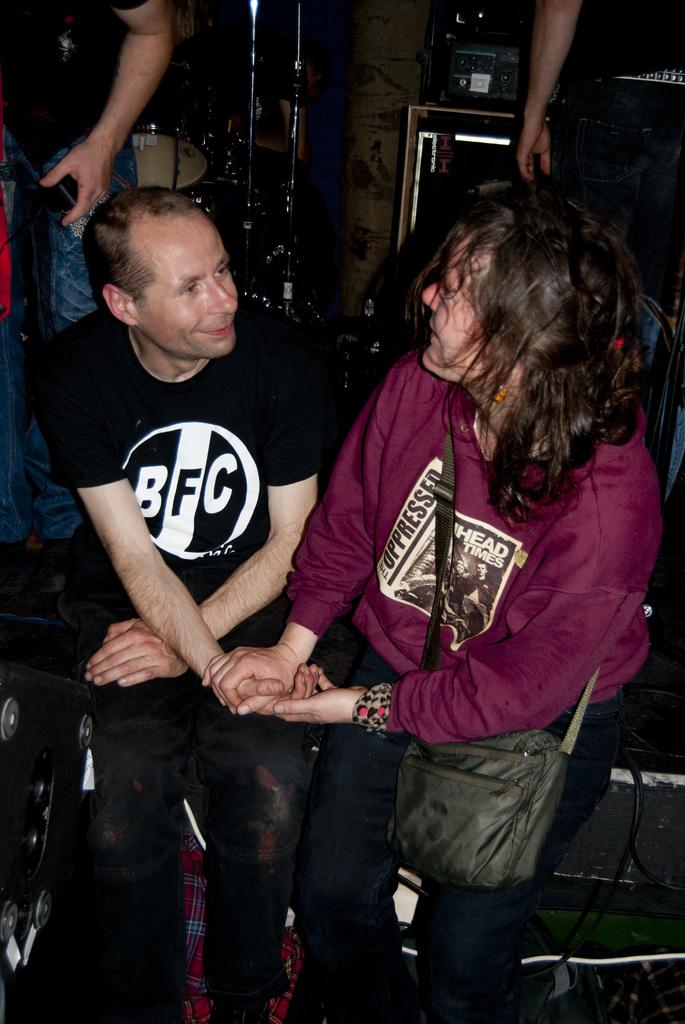<image>
Provide a brief description of the given image. Two people are holding hands with the one on the right having the bfc logo on his chest. 